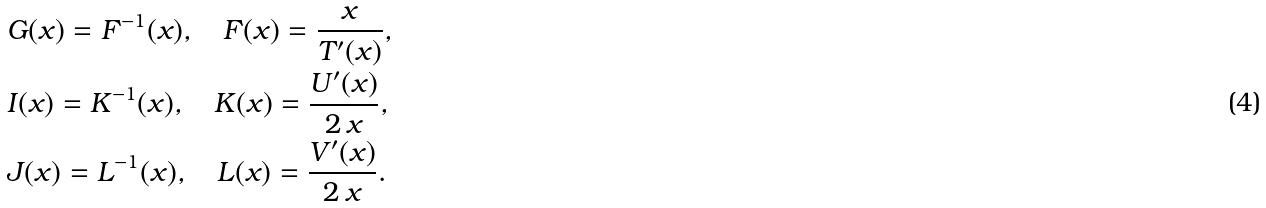<formula> <loc_0><loc_0><loc_500><loc_500>& G ( x ) = F ^ { - 1 } ( x ) , \quad F ( x ) = \frac { x } { T ^ { \prime } ( x ) } , \\ & I ( x ) = K ^ { - 1 } ( x ) , \quad K ( x ) = \frac { U ^ { \prime } ( x ) } { 2 \, x } , \\ & J ( x ) = L ^ { - 1 } ( x ) , \quad L ( x ) = \frac { V ^ { \prime } ( x ) } { 2 \, x } .</formula> 